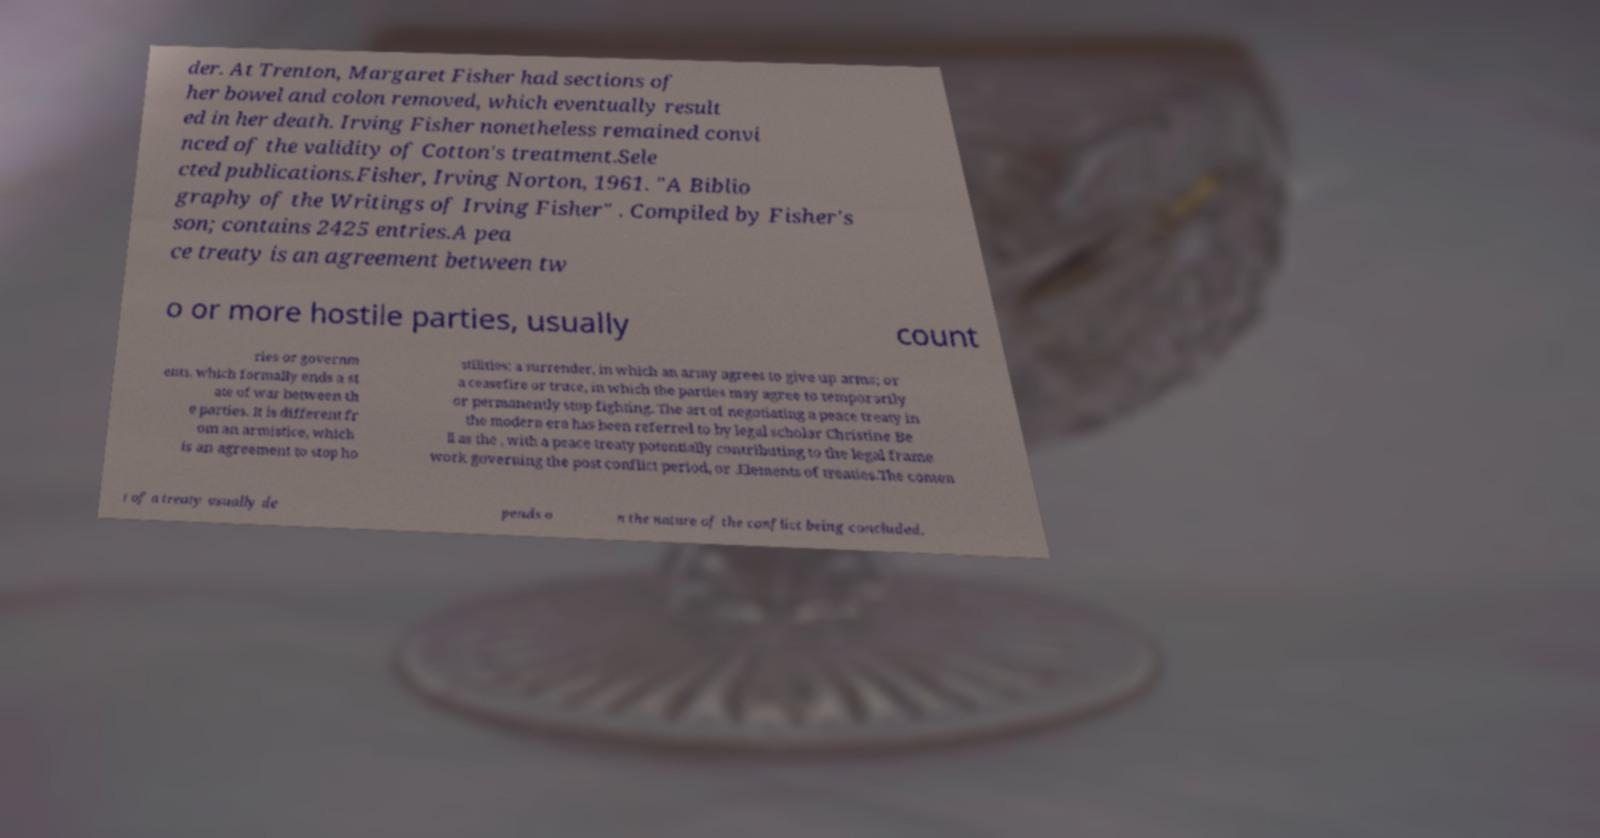Could you extract and type out the text from this image? der. At Trenton, Margaret Fisher had sections of her bowel and colon removed, which eventually result ed in her death. Irving Fisher nonetheless remained convi nced of the validity of Cotton's treatment.Sele cted publications.Fisher, Irving Norton, 1961. "A Biblio graphy of the Writings of Irving Fisher" . Compiled by Fisher's son; contains 2425 entries.A pea ce treaty is an agreement between tw o or more hostile parties, usually count ries or governm ents, which formally ends a st ate of war between th e parties. It is different fr om an armistice, which is an agreement to stop ho stilities; a surrender, in which an army agrees to give up arms; or a ceasefire or truce, in which the parties may agree to temporarily or permanently stop fighting. The art of negotiating a peace treaty in the modern era has been referred to by legal scholar Christine Be ll as the , with a peace treaty potentially contributing to the legal frame work governing the post conflict period, or .Elements of treaties.The conten t of a treaty usually de pends o n the nature of the conflict being concluded. 